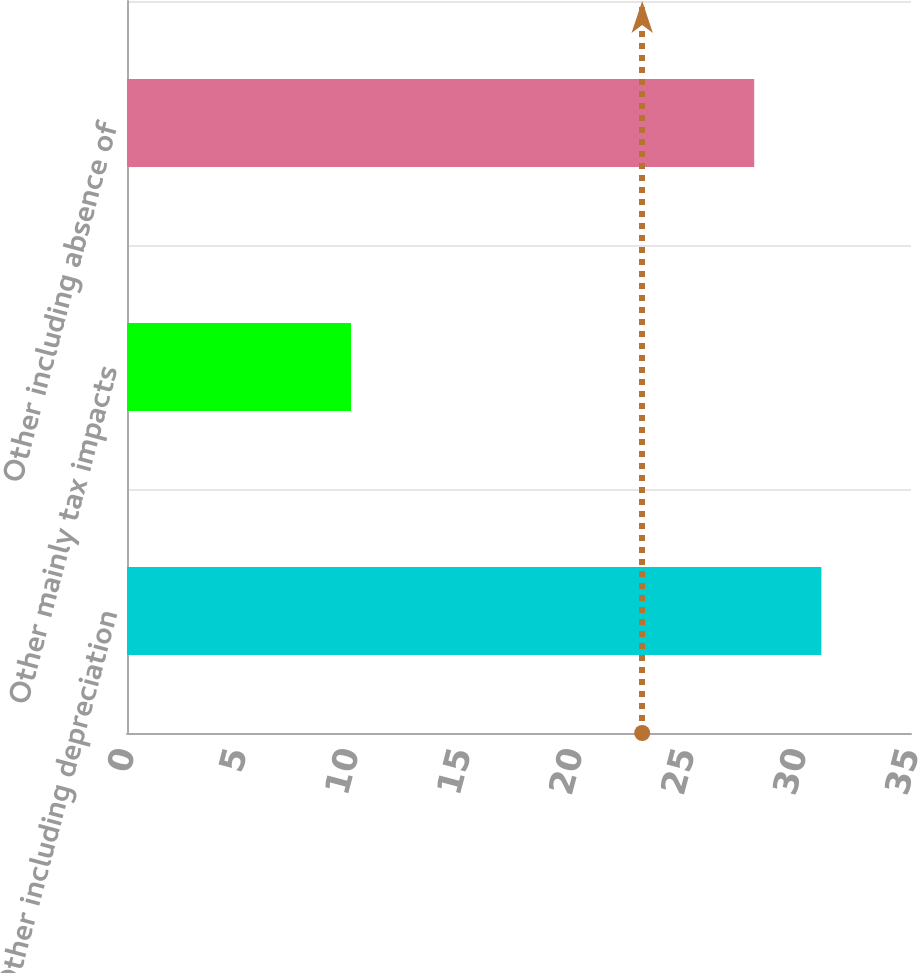<chart> <loc_0><loc_0><loc_500><loc_500><bar_chart><fcel>Other including depreciation<fcel>Other mainly tax impacts<fcel>Other including absence of<nl><fcel>31<fcel>10<fcel>28<nl></chart> 